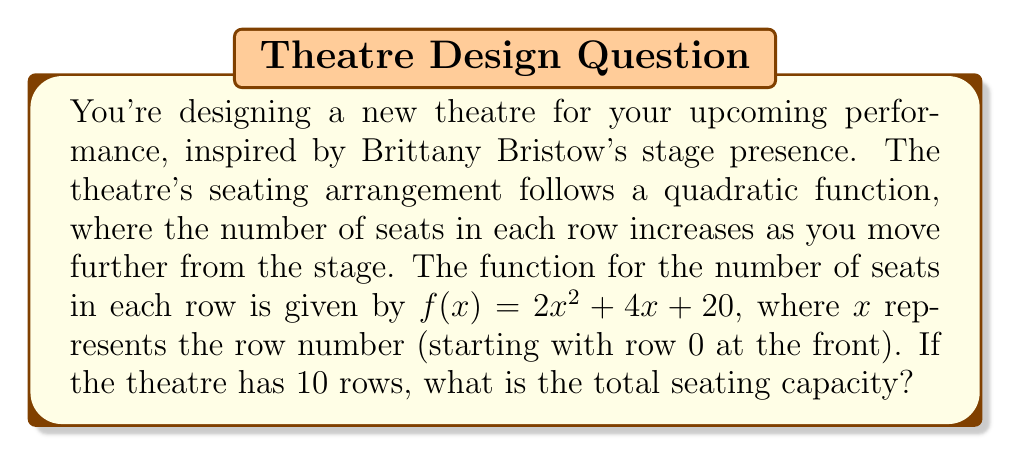Solve this math problem. To solve this problem, we need to follow these steps:

1) The function $f(x) = 2x^2 + 4x + 20$ gives the number of seats in each row.

2) We need to calculate this for each row from 0 to 9 (10 rows total).

3) To get the total capacity, we need to sum these values.

4) This sum can be represented as:

   $$\sum_{x=0}^9 (2x^2 + 4x + 20)$$

5) We can break this into three sums:

   $$2\sum_{x=0}^9 x^2 + 4\sum_{x=0}^9 x + 20\sum_{x=0}^9 1$$

6) We can use the following formulas:
   
   $$\sum_{x=0}^n x^2 = \frac{n(n+1)(2n+1)}{6}$$
   
   $$\sum_{x=0}^n x = \frac{n(n+1)}{2}$$
   
   $$\sum_{x=0}^n 1 = n+1$$

7) Substituting $n=9$ into these formulas:

   $$2 \cdot \frac{9(10)(19)}{6} + 4 \cdot \frac{9(10)}{2} + 20 \cdot 10$$

8) Simplifying:

   $$2 \cdot 285 + 4 \cdot 45 + 200 = 570 + 180 + 200 = 950$$

Therefore, the total seating capacity of the theatre is 950 seats.
Answer: 950 seats 